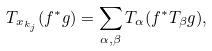<formula> <loc_0><loc_0><loc_500><loc_500>T _ { x _ { k _ { j } } } ( f ^ { * } g ) = \sum _ { \alpha , \beta } T _ { \alpha } ( f ^ { * } T _ { \beta } g ) ,</formula> 